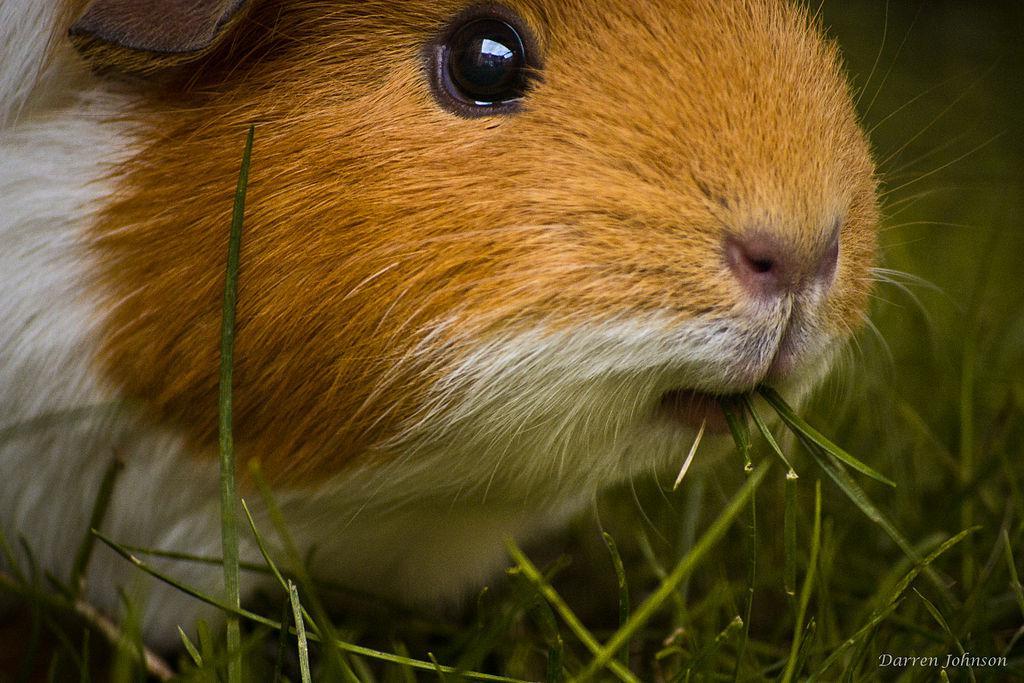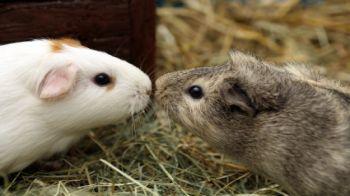The first image is the image on the left, the second image is the image on the right. Evaluate the accuracy of this statement regarding the images: "There is one animal in the image on the left.". Is it true? Answer yes or no. Yes. 